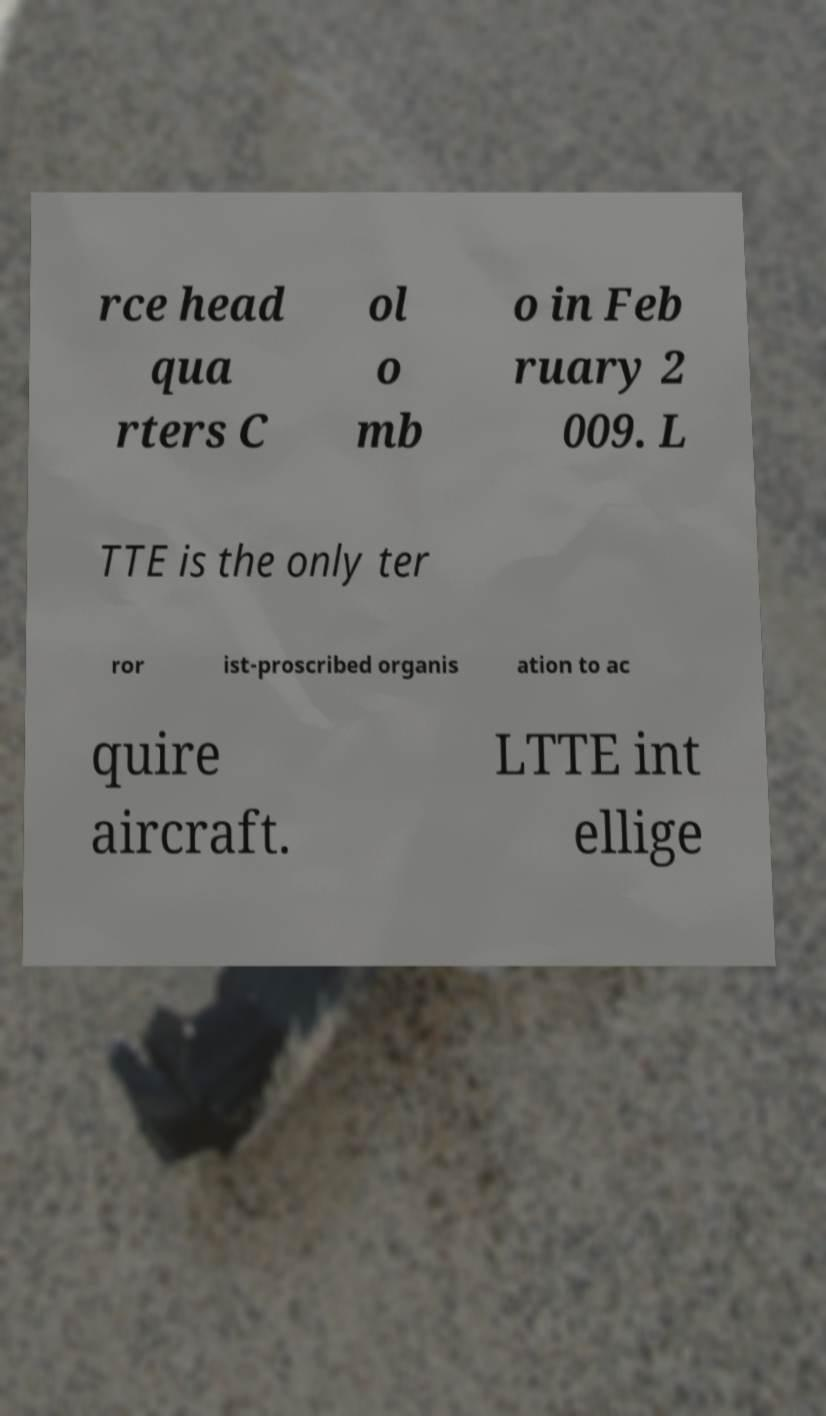There's text embedded in this image that I need extracted. Can you transcribe it verbatim? rce head qua rters C ol o mb o in Feb ruary 2 009. L TTE is the only ter ror ist-proscribed organis ation to ac quire aircraft. LTTE int ellige 